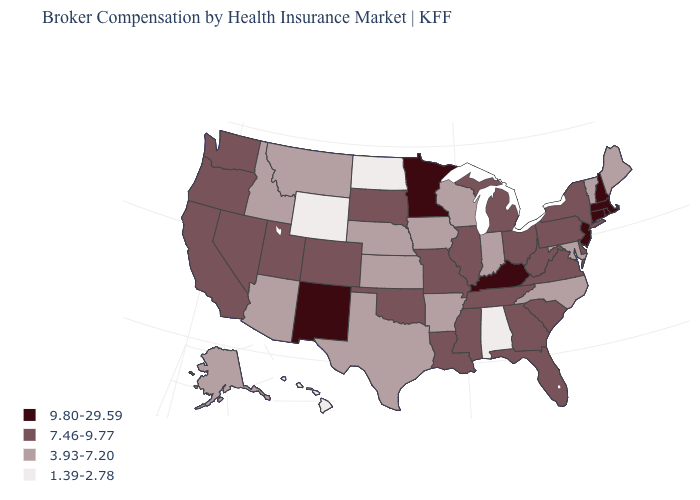Which states have the lowest value in the Northeast?
Be succinct. Maine, Vermont. What is the value of Michigan?
Answer briefly. 7.46-9.77. Name the states that have a value in the range 3.93-7.20?
Concise answer only. Alaska, Arizona, Arkansas, Idaho, Indiana, Iowa, Kansas, Maine, Maryland, Montana, Nebraska, North Carolina, Texas, Vermont, Wisconsin. Which states hav the highest value in the MidWest?
Short answer required. Minnesota. Does the first symbol in the legend represent the smallest category?
Keep it brief. No. Among the states that border Georgia , does Alabama have the lowest value?
Keep it brief. Yes. Name the states that have a value in the range 3.93-7.20?
Concise answer only. Alaska, Arizona, Arkansas, Idaho, Indiana, Iowa, Kansas, Maine, Maryland, Montana, Nebraska, North Carolina, Texas, Vermont, Wisconsin. Does Missouri have the highest value in the USA?
Concise answer only. No. What is the value of Vermont?
Short answer required. 3.93-7.20. Name the states that have a value in the range 1.39-2.78?
Be succinct. Alabama, Hawaii, North Dakota, Wyoming. Name the states that have a value in the range 3.93-7.20?
Quick response, please. Alaska, Arizona, Arkansas, Idaho, Indiana, Iowa, Kansas, Maine, Maryland, Montana, Nebraska, North Carolina, Texas, Vermont, Wisconsin. What is the value of New York?
Short answer required. 7.46-9.77. Does the first symbol in the legend represent the smallest category?
Write a very short answer. No. What is the value of Texas?
Be succinct. 3.93-7.20. Which states hav the highest value in the Northeast?
Short answer required. Connecticut, Massachusetts, New Hampshire, New Jersey, Rhode Island. 